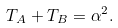Convert formula to latex. <formula><loc_0><loc_0><loc_500><loc_500>T _ { A } + T _ { B } = \alpha ^ { 2 } .</formula> 